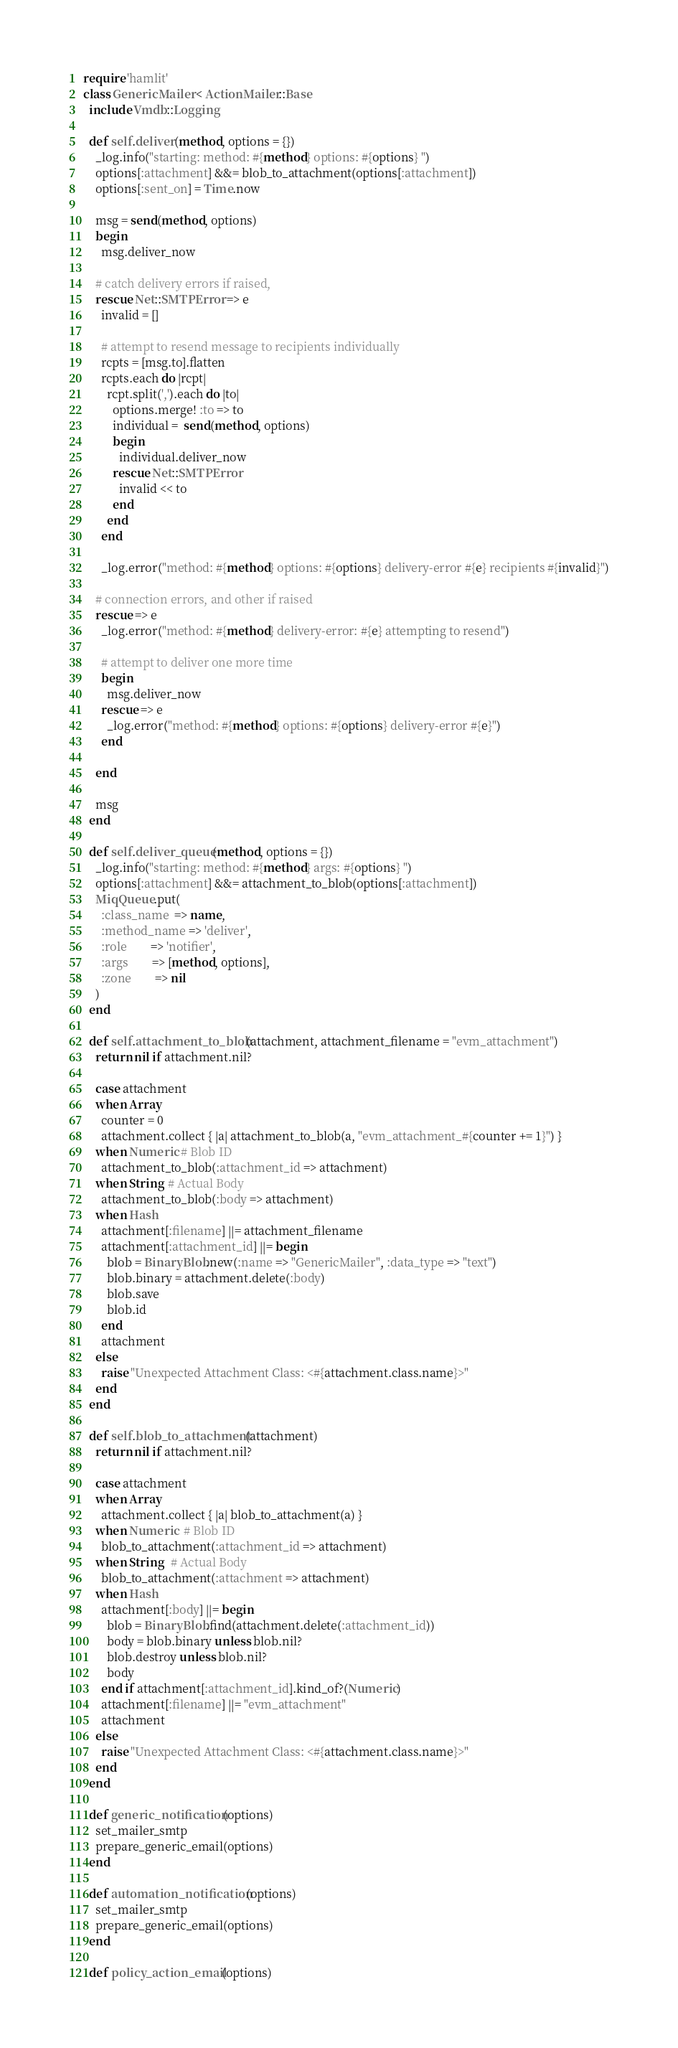<code> <loc_0><loc_0><loc_500><loc_500><_Ruby_>require 'hamlit'
class GenericMailer < ActionMailer::Base
  include Vmdb::Logging

  def self.deliver(method, options = {})
    _log.info("starting: method: #{method} options: #{options} ")
    options[:attachment] &&= blob_to_attachment(options[:attachment])
    options[:sent_on] = Time.now

    msg = send(method, options)
    begin
      msg.deliver_now

    # catch delivery errors if raised,
    rescue Net::SMTPError => e
      invalid = []

      # attempt to resend message to recipients individually
      rcpts = [msg.to].flatten
      rcpts.each do |rcpt|
        rcpt.split(',').each do |to|
          options.merge! :to => to
          individual =  send(method, options)
          begin
            individual.deliver_now
          rescue Net::SMTPError
            invalid << to
          end
        end
      end

      _log.error("method: #{method} options: #{options} delivery-error #{e} recipients #{invalid}")

    # connection errors, and other if raised
    rescue => e
      _log.error("method: #{method} delivery-error: #{e} attempting to resend")

      # attempt to deliver one more time
      begin
        msg.deliver_now
      rescue => e
        _log.error("method: #{method} options: #{options} delivery-error #{e}")
      end

    end

    msg
  end

  def self.deliver_queue(method, options = {})
    _log.info("starting: method: #{method} args: #{options} ")
    options[:attachment] &&= attachment_to_blob(options[:attachment])
    MiqQueue.put(
      :class_name  => name,
      :method_name => 'deliver',
      :role        => 'notifier',
      :args        => [method, options],
      :zone        => nil
    )
  end

  def self.attachment_to_blob(attachment, attachment_filename = "evm_attachment")
    return nil if attachment.nil?

    case attachment
    when Array
      counter = 0
      attachment.collect { |a| attachment_to_blob(a, "evm_attachment_#{counter += 1}") }
    when Numeric # Blob ID
      attachment_to_blob(:attachment_id => attachment)
    when String  # Actual Body
      attachment_to_blob(:body => attachment)
    when Hash
      attachment[:filename] ||= attachment_filename
      attachment[:attachment_id] ||= begin
        blob = BinaryBlob.new(:name => "GenericMailer", :data_type => "text")
        blob.binary = attachment.delete(:body)
        blob.save
        blob.id
      end
      attachment
    else
      raise "Unexpected Attachment Class: <#{attachment.class.name}>"
    end
  end

  def self.blob_to_attachment(attachment)
    return nil if attachment.nil?

    case attachment
    when Array
      attachment.collect { |a| blob_to_attachment(a) }
    when Numeric  # Blob ID
      blob_to_attachment(:attachment_id => attachment)
    when String   # Actual Body
      blob_to_attachment(:attachment => attachment)
    when Hash
      attachment[:body] ||= begin
        blob = BinaryBlob.find(attachment.delete(:attachment_id))
        body = blob.binary unless blob.nil?
        blob.destroy unless blob.nil?
        body
      end if attachment[:attachment_id].kind_of?(Numeric)
      attachment[:filename] ||= "evm_attachment"
      attachment
    else
      raise "Unexpected Attachment Class: <#{attachment.class.name}>"
    end
  end

  def generic_notification(options)
    set_mailer_smtp
    prepare_generic_email(options)
  end

  def automation_notification(options)
    set_mailer_smtp
    prepare_generic_email(options)
  end

  def policy_action_email(options)</code> 